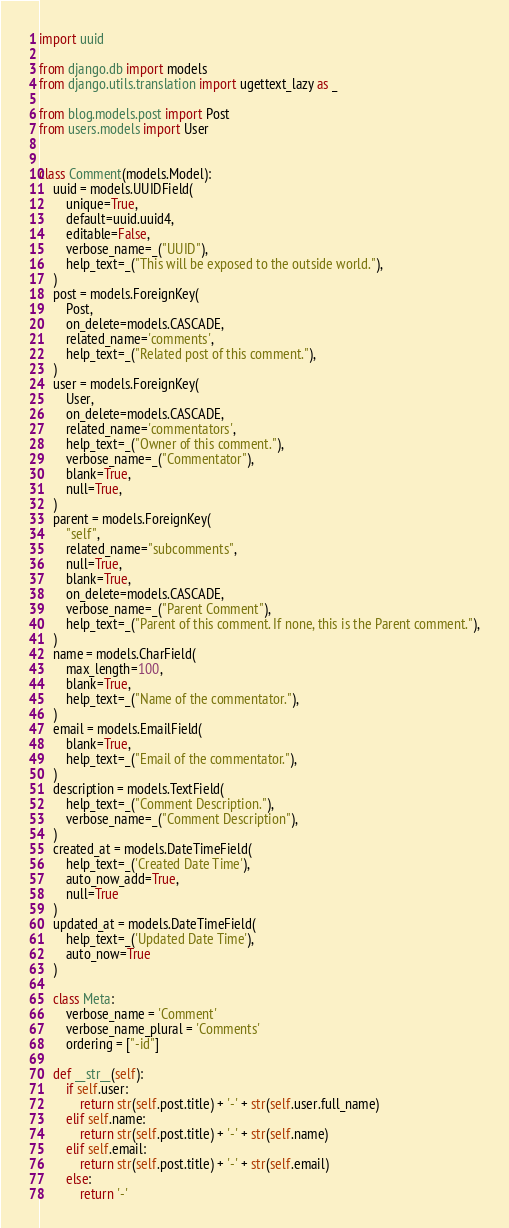Convert code to text. <code><loc_0><loc_0><loc_500><loc_500><_Python_>import uuid

from django.db import models
from django.utils.translation import ugettext_lazy as _

from blog.models.post import Post
from users.models import User


class Comment(models.Model):
    uuid = models.UUIDField(
        unique=True,
        default=uuid.uuid4,
        editable=False,
        verbose_name=_("UUID"),
        help_text=_("This will be exposed to the outside world."),
    )
    post = models.ForeignKey(
        Post,
        on_delete=models.CASCADE,
        related_name='comments',
        help_text=_("Related post of this comment."),
    )
    user = models.ForeignKey(
        User,
        on_delete=models.CASCADE,
        related_name='commentators',
        help_text=_("Owner of this comment."),
        verbose_name=_("Commentator"),
        blank=True,
        null=True,
    )
    parent = models.ForeignKey(
        "self",
        related_name="subcomments",
        null=True,
        blank=True,
        on_delete=models.CASCADE,
        verbose_name=_("Parent Comment"),
        help_text=_("Parent of this comment. If none, this is the Parent comment."),
    )
    name = models.CharField(
        max_length=100,
        blank=True,
        help_text=_("Name of the commentator."),
    )
    email = models.EmailField(
        blank=True,
        help_text=_("Email of the commentator."),
    )
    description = models.TextField(
        help_text=_("Comment Description."),
        verbose_name=_("Comment Description"),
    )
    created_at = models.DateTimeField(
        help_text=_('Created Date Time'),
        auto_now_add=True,
        null=True
    )
    updated_at = models.DateTimeField(
        help_text=_('Updated Date Time'),
        auto_now=True
    )

    class Meta:
        verbose_name = 'Comment'
        verbose_name_plural = 'Comments'
        ordering = ["-id"]

    def __str__(self):
        if self.user:
            return str(self.post.title) + '-' + str(self.user.full_name)
        elif self.name:
            return str(self.post.title) + '-' + str(self.name)
        elif self.email:
            return str(self.post.title) + '-' + str(self.email)
        else:
            return '-'
</code> 